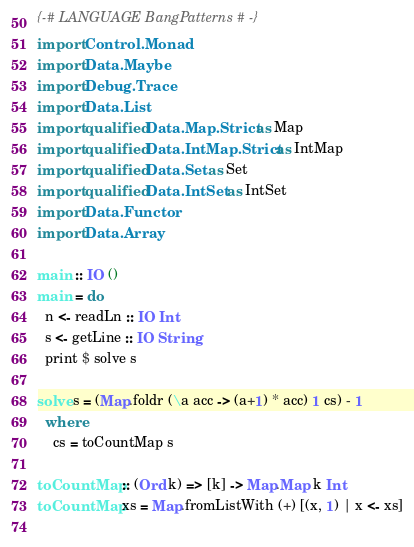Convert code to text. <code><loc_0><loc_0><loc_500><loc_500><_Haskell_>{-# LANGUAGE BangPatterns #-}
import Control.Monad
import Data.Maybe
import Debug.Trace
import Data.List
import qualified Data.Map.Strict as Map
import qualified Data.IntMap.Strict as IntMap
import qualified Data.Set as Set
import qualified Data.IntSet as IntSet
import Data.Functor
import Data.Array

main :: IO ()
main = do
  n <- readLn :: IO Int
  s <- getLine :: IO String
  print $ solve s
 
solve s = (Map.foldr (\a acc -> (a+1) * acc) 1 cs) - 1
  where
    cs = toCountMap s

toCountMap :: (Ord k) => [k] -> Map.Map k Int
toCountMap xs = Map.fromListWith (+) [(x, 1) | x <- xs]
      </code> 